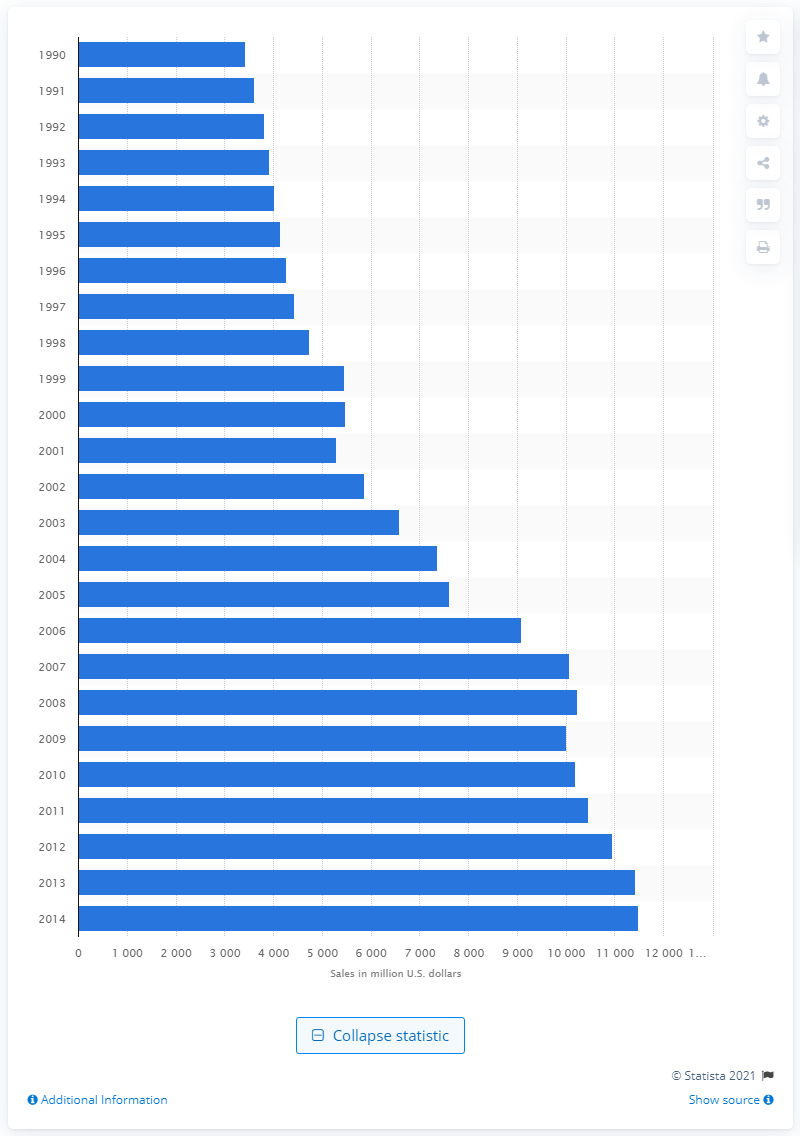Draw attention to some important aspects in this diagram. In 2013, the amount of money spent on alcoholic beverages consumed away from home in the United States was 11,415. 